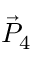<formula> <loc_0><loc_0><loc_500><loc_500>\vec { P } _ { 4 }</formula> 